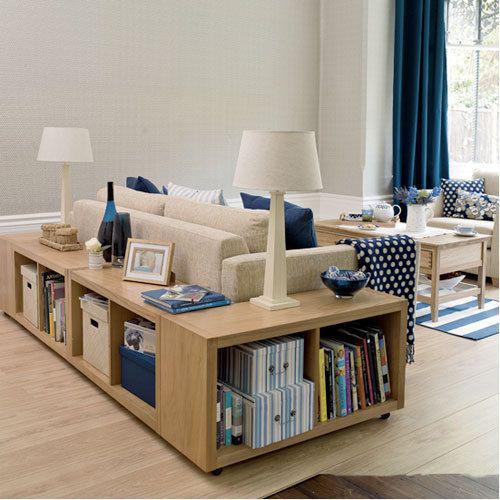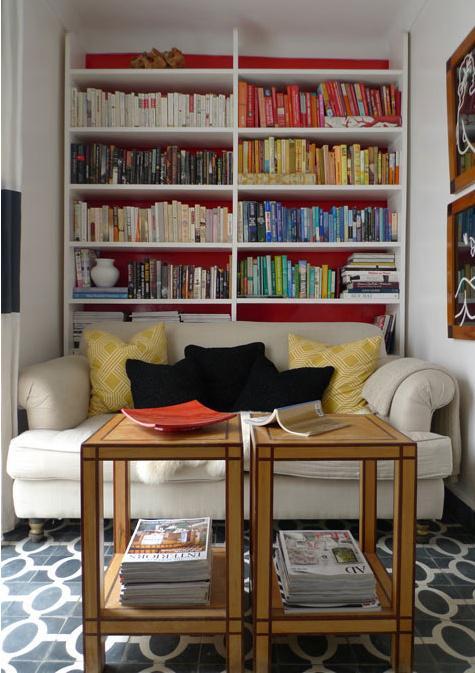The first image is the image on the left, the second image is the image on the right. Given the left and right images, does the statement "there is a bookself with a rug on a wood floor" hold true? Answer yes or no. Yes. 